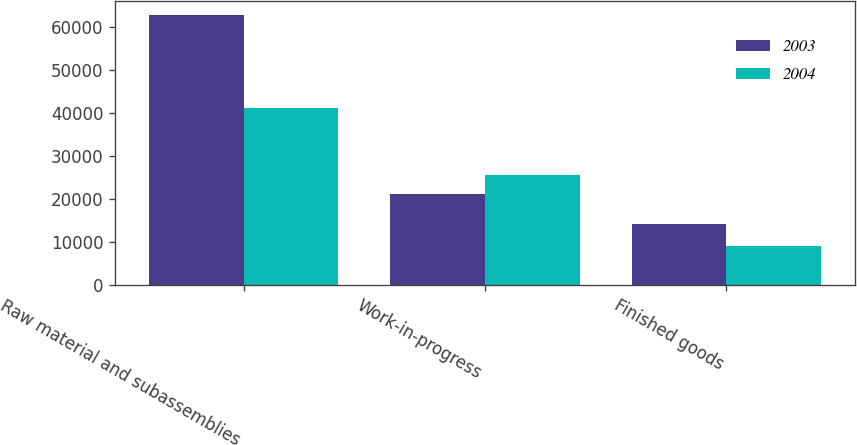Convert chart to OTSL. <chart><loc_0><loc_0><loc_500><loc_500><stacked_bar_chart><ecel><fcel>Raw material and subassemblies<fcel>Work-in-progress<fcel>Finished goods<nl><fcel>2003<fcel>62906<fcel>21181<fcel>14171<nl><fcel>2004<fcel>41190<fcel>25682<fcel>9087<nl></chart> 